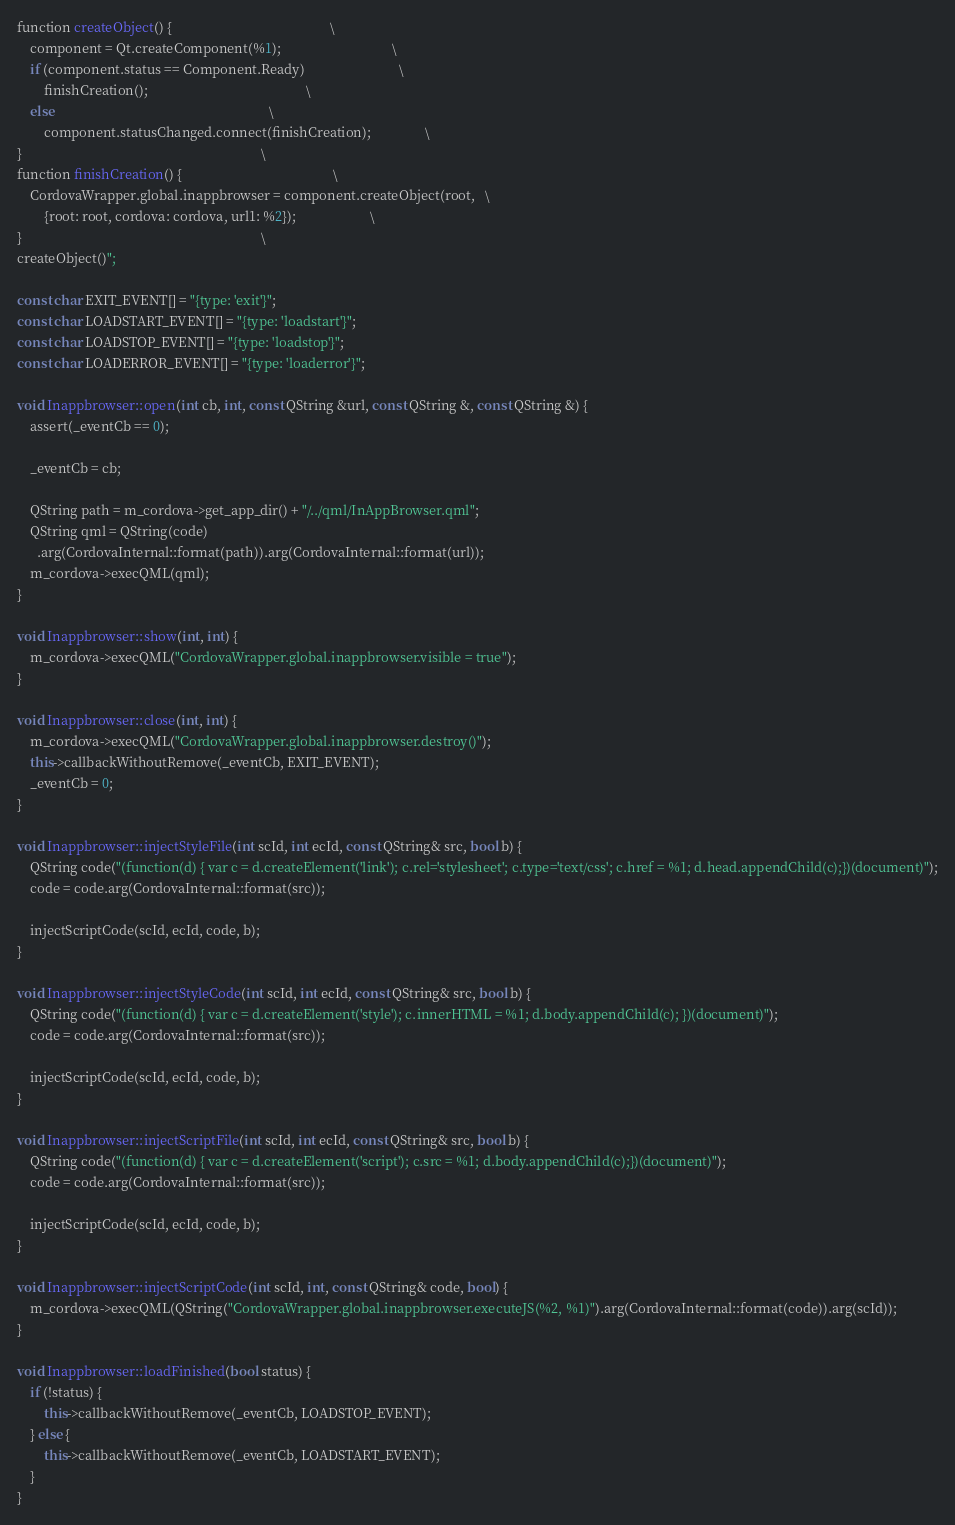Convert code to text. <code><loc_0><loc_0><loc_500><loc_500><_C++_>function createObject() {                                               \
    component = Qt.createComponent(%1);                                 \
    if (component.status == Component.Ready)                            \
        finishCreation();                                               \
    else                                                                \
        component.statusChanged.connect(finishCreation);                \
}                                                                       \
function finishCreation() {                                             \
    CordovaWrapper.global.inappbrowser = component.createObject(root,   \
        {root: root, cordova: cordova, url1: %2});                      \
}                                                                       \
createObject()";

const char EXIT_EVENT[] = "{type: 'exit'}";
const char LOADSTART_EVENT[] = "{type: 'loadstart'}";
const char LOADSTOP_EVENT[] = "{type: 'loadstop'}";
const char LOADERROR_EVENT[] = "{type: 'loaderror'}";

void Inappbrowser::open(int cb, int, const QString &url, const QString &, const QString &) {
    assert(_eventCb == 0);

    _eventCb = cb;

    QString path = m_cordova->get_app_dir() + "/../qml/InAppBrowser.qml";
    QString qml = QString(code)
      .arg(CordovaInternal::format(path)).arg(CordovaInternal::format(url));
    m_cordova->execQML(qml);
}

void Inappbrowser::show(int, int) {
    m_cordova->execQML("CordovaWrapper.global.inappbrowser.visible = true");
}

void Inappbrowser::close(int, int) {
    m_cordova->execQML("CordovaWrapper.global.inappbrowser.destroy()");
    this->callbackWithoutRemove(_eventCb, EXIT_EVENT);
    _eventCb = 0;
}

void Inappbrowser::injectStyleFile(int scId, int ecId, const QString& src, bool b) {
    QString code("(function(d) { var c = d.createElement('link'); c.rel='stylesheet'; c.type='text/css'; c.href = %1; d.head.appendChild(c);})(document)");
    code = code.arg(CordovaInternal::format(src));

    injectScriptCode(scId, ecId, code, b);
}

void Inappbrowser::injectStyleCode(int scId, int ecId, const QString& src, bool b) {
    QString code("(function(d) { var c = d.createElement('style'); c.innerHTML = %1; d.body.appendChild(c); })(document)");
    code = code.arg(CordovaInternal::format(src));

    injectScriptCode(scId, ecId, code, b);
}

void Inappbrowser::injectScriptFile(int scId, int ecId, const QString& src, bool b) {
    QString code("(function(d) { var c = d.createElement('script'); c.src = %1; d.body.appendChild(c);})(document)");
    code = code.arg(CordovaInternal::format(src));

    injectScriptCode(scId, ecId, code, b);
}

void Inappbrowser::injectScriptCode(int scId, int, const QString& code, bool) {
    m_cordova->execQML(QString("CordovaWrapper.global.inappbrowser.executeJS(%2, %1)").arg(CordovaInternal::format(code)).arg(scId));
}

void Inappbrowser::loadFinished(bool status) {
    if (!status) {
        this->callbackWithoutRemove(_eventCb, LOADSTOP_EVENT);
    } else {
        this->callbackWithoutRemove(_eventCb, LOADSTART_EVENT);
    }
}
</code> 